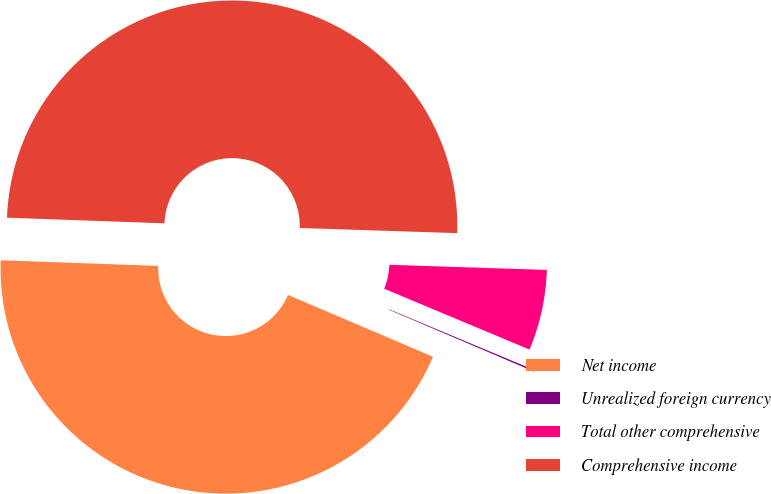Convert chart to OTSL. <chart><loc_0><loc_0><loc_500><loc_500><pie_chart><fcel>Net income<fcel>Unrealized foreign currency<fcel>Total other comprehensive<fcel>Comprehensive income<nl><fcel>44.16%<fcel>0.11%<fcel>5.79%<fcel>49.95%<nl></chart> 